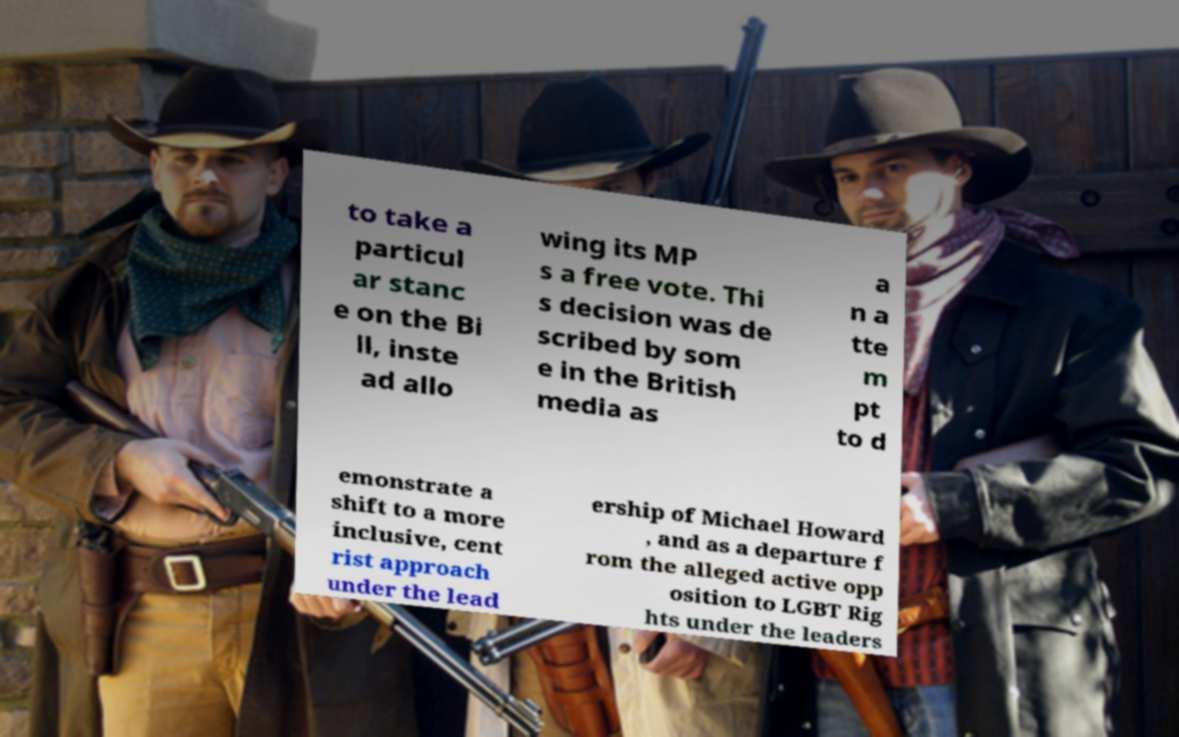For documentation purposes, I need the text within this image transcribed. Could you provide that? to take a particul ar stanc e on the Bi ll, inste ad allo wing its MP s a free vote. Thi s decision was de scribed by som e in the British media as a n a tte m pt to d emonstrate a shift to a more inclusive, cent rist approach under the lead ership of Michael Howard , and as a departure f rom the alleged active opp osition to LGBT Rig hts under the leaders 